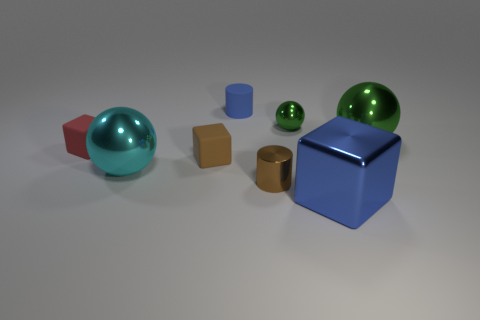Subtract all tiny rubber cubes. How many cubes are left? 1 Subtract 3 blocks. How many blocks are left? 0 Add 1 shiny cylinders. How many objects exist? 9 Subtract all brown blocks. How many blocks are left? 2 Subtract 0 gray cylinders. How many objects are left? 8 Subtract all spheres. How many objects are left? 5 Subtract all red blocks. Subtract all red cylinders. How many blocks are left? 2 Subtract all blue cubes. How many green spheres are left? 2 Subtract all tiny matte things. Subtract all small cyan metal cylinders. How many objects are left? 5 Add 7 small green objects. How many small green objects are left? 8 